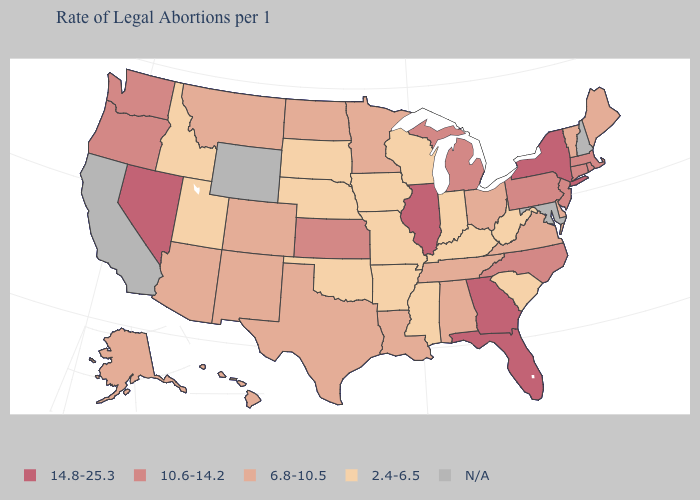How many symbols are there in the legend?
Keep it brief. 5. Name the states that have a value in the range 10.6-14.2?
Concise answer only. Connecticut, Kansas, Massachusetts, Michigan, New Jersey, North Carolina, Oregon, Pennsylvania, Rhode Island, Washington. How many symbols are there in the legend?
Give a very brief answer. 5. How many symbols are there in the legend?
Quick response, please. 5. What is the value of New Jersey?
Short answer required. 10.6-14.2. Name the states that have a value in the range 10.6-14.2?
Concise answer only. Connecticut, Kansas, Massachusetts, Michigan, New Jersey, North Carolina, Oregon, Pennsylvania, Rhode Island, Washington. How many symbols are there in the legend?
Quick response, please. 5. What is the lowest value in the Northeast?
Concise answer only. 6.8-10.5. Name the states that have a value in the range 2.4-6.5?
Keep it brief. Arkansas, Idaho, Indiana, Iowa, Kentucky, Mississippi, Missouri, Nebraska, Oklahoma, South Carolina, South Dakota, Utah, West Virginia, Wisconsin. Does Ohio have the lowest value in the MidWest?
Concise answer only. No. Which states have the highest value in the USA?
Short answer required. Florida, Georgia, Illinois, Nevada, New York. What is the value of Colorado?
Keep it brief. 6.8-10.5. What is the value of Florida?
Quick response, please. 14.8-25.3. Does Massachusetts have the highest value in the USA?
Write a very short answer. No. 